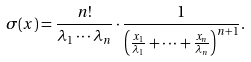<formula> <loc_0><loc_0><loc_500><loc_500>\sigma ( x ) = \frac { n ! } { \lambda _ { 1 } \cdots \lambda _ { n } } \cdot \frac { 1 } { \left ( \frac { x _ { 1 } } { \lambda _ { 1 } } + \cdots + \frac { x _ { n } } { \lambda _ { n } } \right ) ^ { n + 1 } } .</formula> 